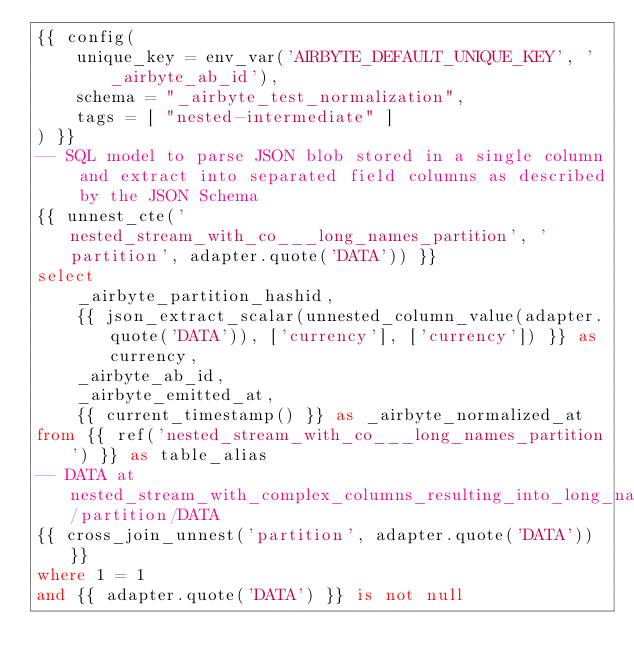Convert code to text. <code><loc_0><loc_0><loc_500><loc_500><_SQL_>{{ config(
    unique_key = env_var('AIRBYTE_DEFAULT_UNIQUE_KEY', '_airbyte_ab_id'),
    schema = "_airbyte_test_normalization",
    tags = [ "nested-intermediate" ]
) }}
-- SQL model to parse JSON blob stored in a single column and extract into separated field columns as described by the JSON Schema
{{ unnest_cte('nested_stream_with_co___long_names_partition', 'partition', adapter.quote('DATA')) }}
select
    _airbyte_partition_hashid,
    {{ json_extract_scalar(unnested_column_value(adapter.quote('DATA')), ['currency'], ['currency']) }} as currency,
    _airbyte_ab_id,
    _airbyte_emitted_at,
    {{ current_timestamp() }} as _airbyte_normalized_at
from {{ ref('nested_stream_with_co___long_names_partition') }} as table_alias
-- DATA at nested_stream_with_complex_columns_resulting_into_long_names/partition/DATA
{{ cross_join_unnest('partition', adapter.quote('DATA')) }}
where 1 = 1
and {{ adapter.quote('DATA') }} is not null

</code> 